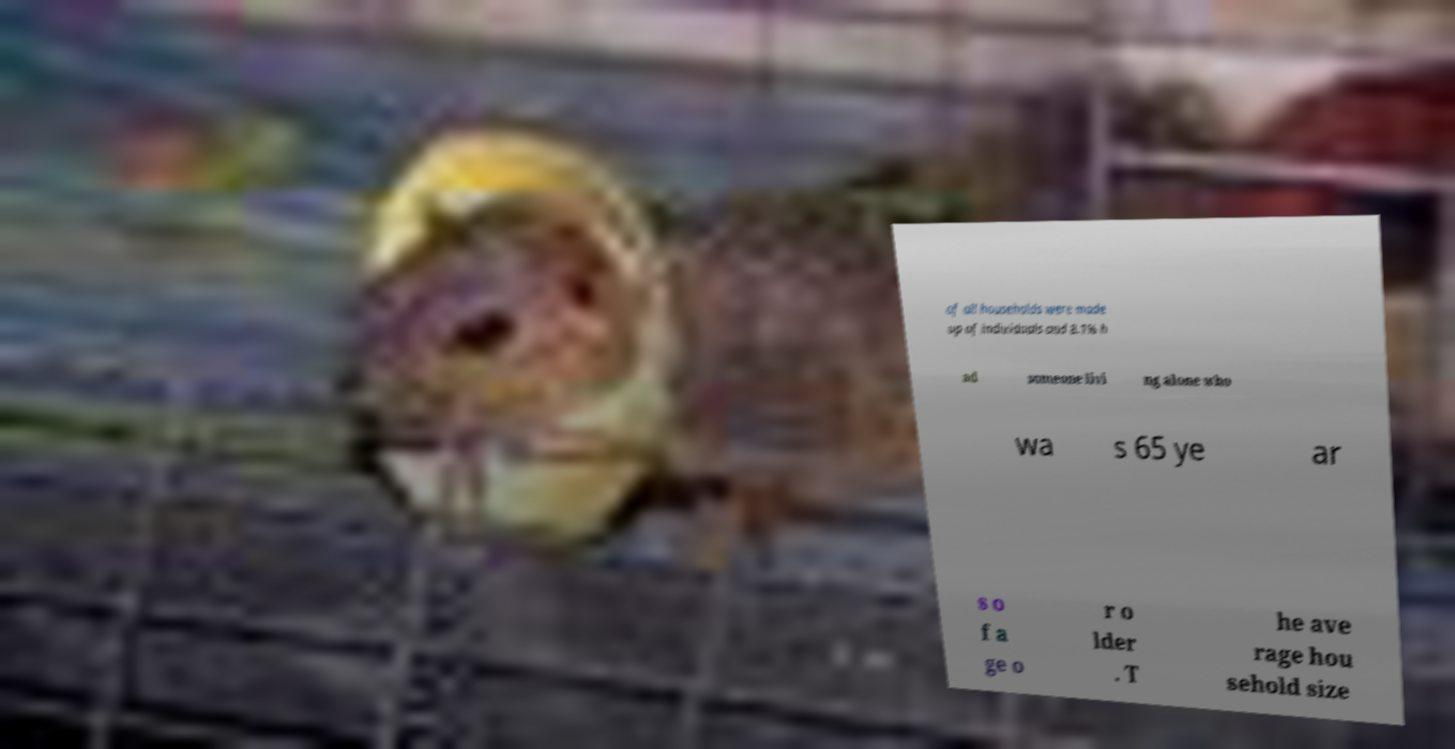Can you accurately transcribe the text from the provided image for me? of all households were made up of individuals and 8.1% h ad someone livi ng alone who wa s 65 ye ar s o f a ge o r o lder . T he ave rage hou sehold size 